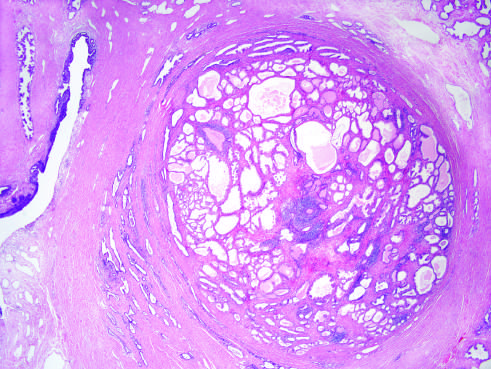s low magnification caused predominantly by stromal, rather than glandular, proliferation in other cases of nodular hyperplasia?
Answer the question using a single word or phrase. No 